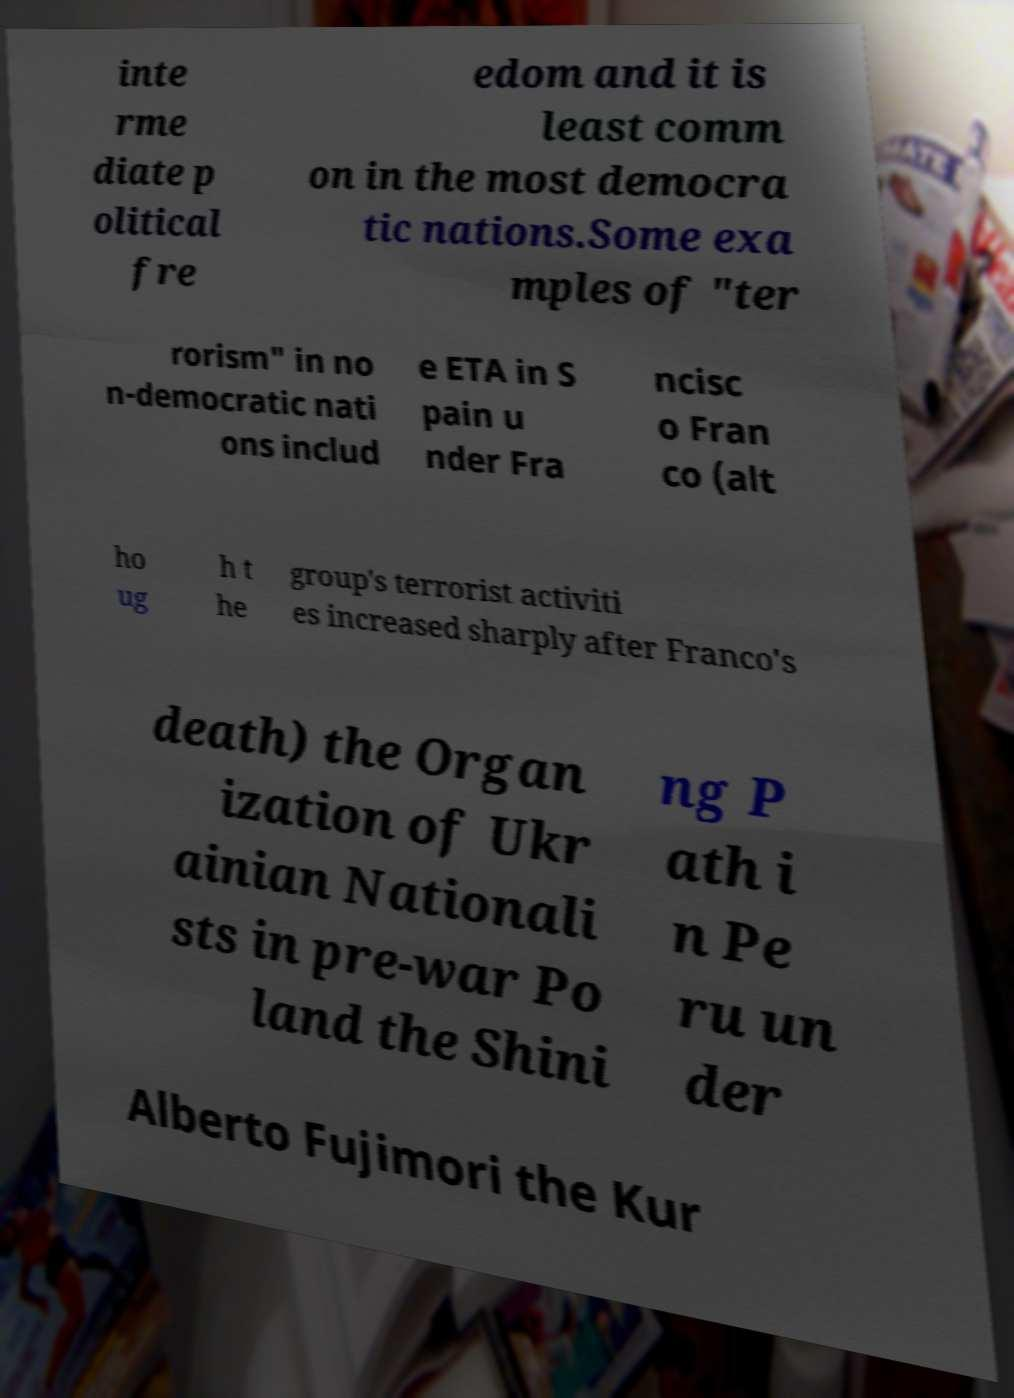What messages or text are displayed in this image? I need them in a readable, typed format. inte rme diate p olitical fre edom and it is least comm on in the most democra tic nations.Some exa mples of "ter rorism" in no n-democratic nati ons includ e ETA in S pain u nder Fra ncisc o Fran co (alt ho ug h t he group's terrorist activiti es increased sharply after Franco's death) the Organ ization of Ukr ainian Nationali sts in pre-war Po land the Shini ng P ath i n Pe ru un der Alberto Fujimori the Kur 